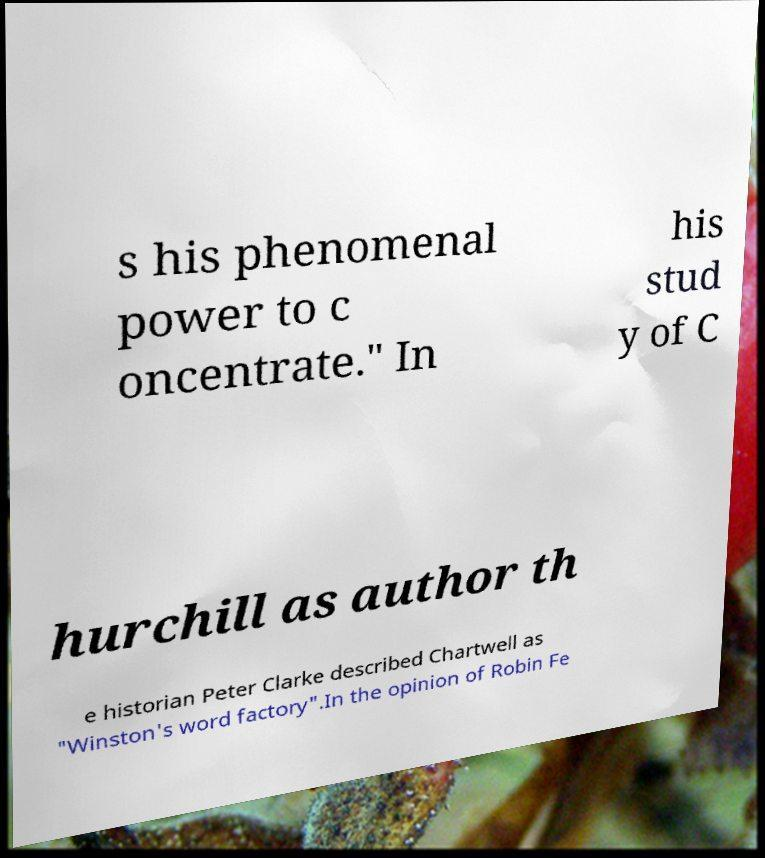Can you accurately transcribe the text from the provided image for me? s his phenomenal power to c oncentrate." In his stud y of C hurchill as author th e historian Peter Clarke described Chartwell as "Winston's word factory".In the opinion of Robin Fe 